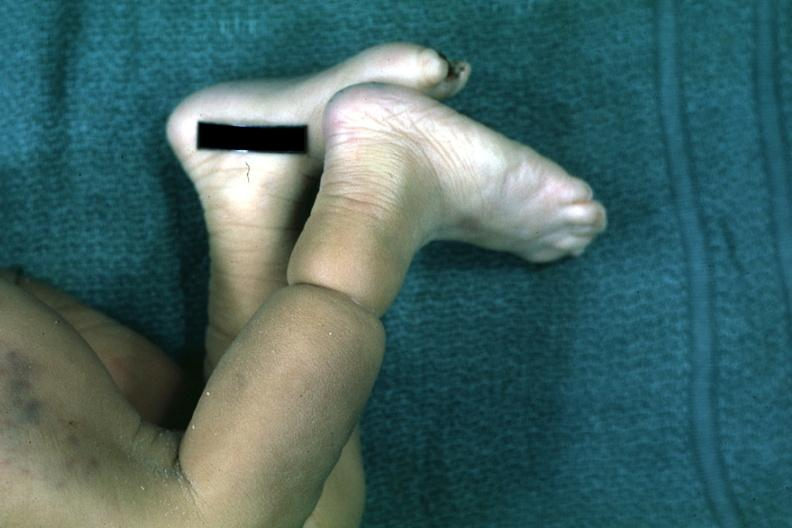does this image show called streeters band whatever that is looks like an amniotic band lesion?
Answer the question using a single word or phrase. Yes 